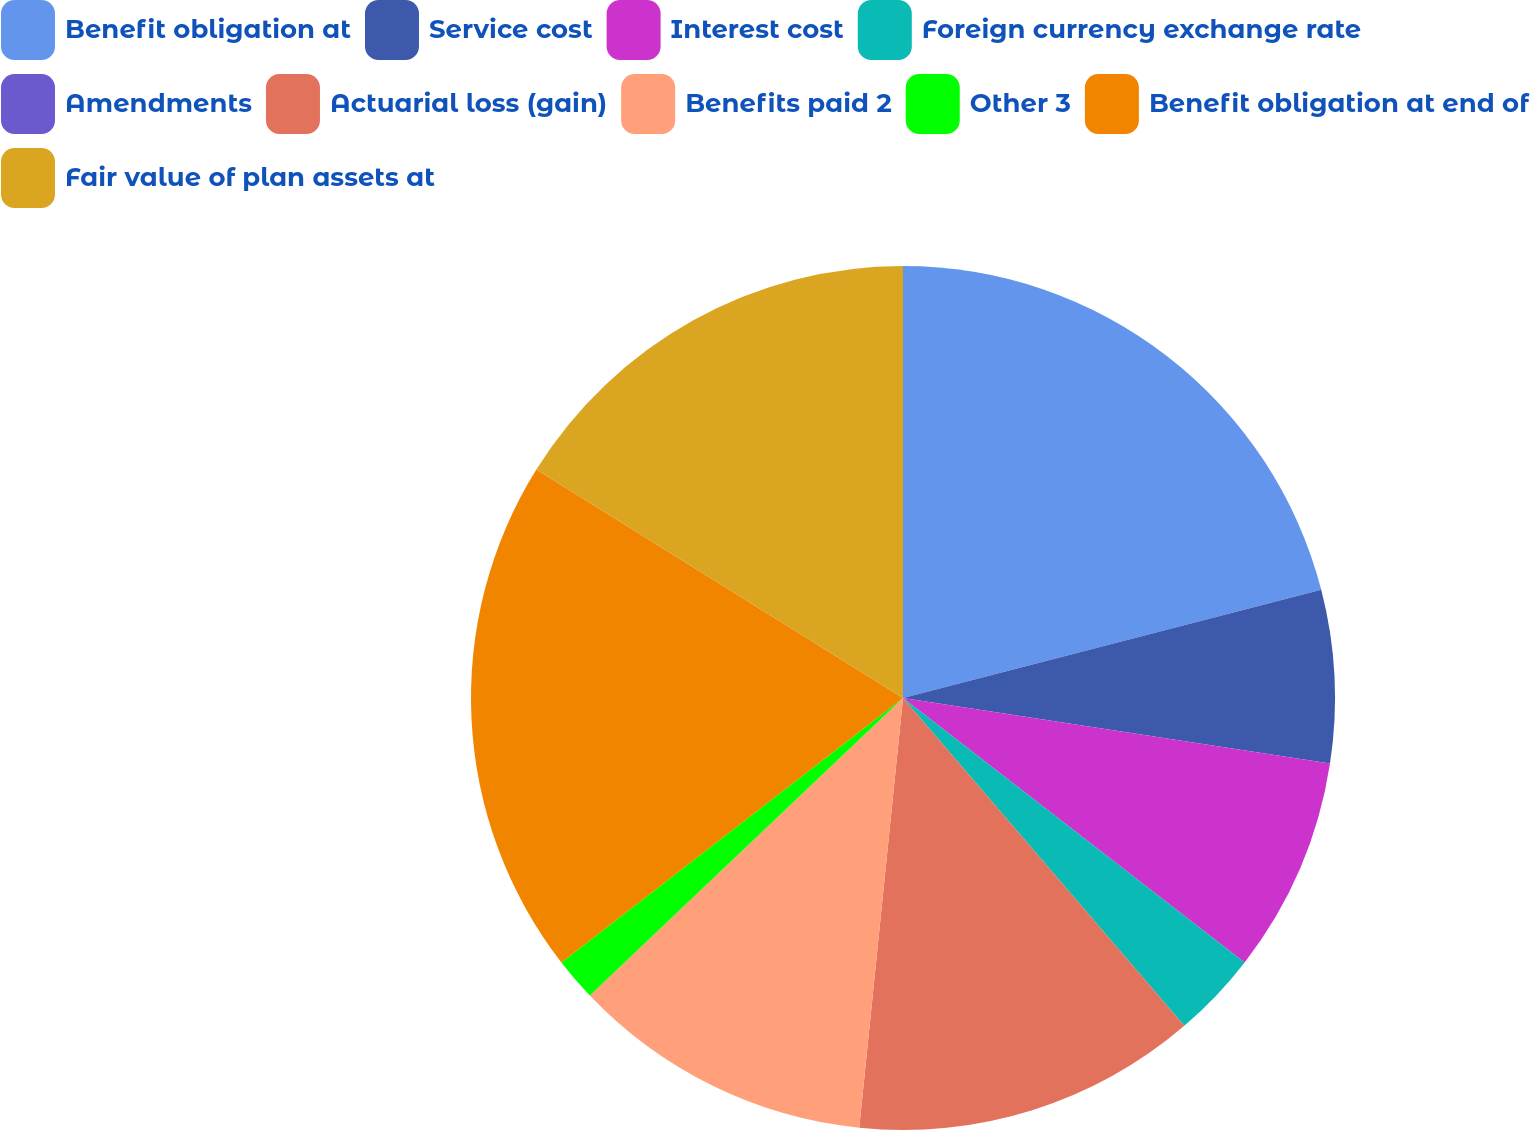Convert chart to OTSL. <chart><loc_0><loc_0><loc_500><loc_500><pie_chart><fcel>Benefit obligation at<fcel>Service cost<fcel>Interest cost<fcel>Foreign currency exchange rate<fcel>Amendments<fcel>Actuarial loss (gain)<fcel>Benefits paid 2<fcel>Other 3<fcel>Benefit obligation at end of<fcel>Fair value of plan assets at<nl><fcel>20.97%<fcel>6.45%<fcel>8.06%<fcel>3.23%<fcel>0.0%<fcel>12.9%<fcel>11.29%<fcel>1.61%<fcel>19.35%<fcel>16.13%<nl></chart> 